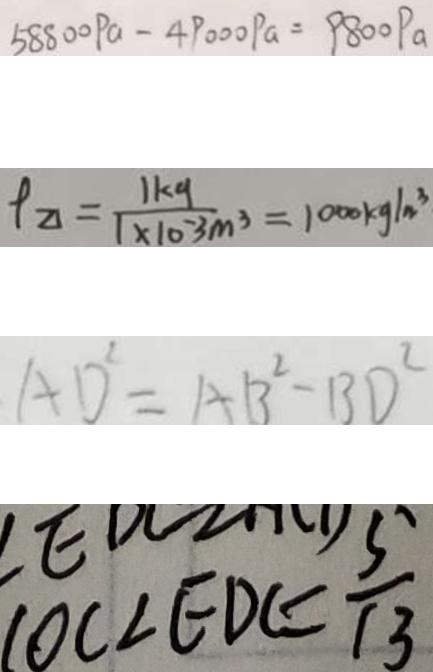Convert formula to latex. <formula><loc_0><loc_0><loc_500><loc_500>5 8 8 0 0 P a - 4 9 0 0 0 P a = 9 8 0 0 P a 
 \rho _ { \Delta } = \frac { 1 k g } { 1 \times 1 0 ^ { - 3 } m ^ { 3 } } = 1 0 0 0 k g / m ^ { 3 } 
 A D ^ { 2 } = A B ^ { 2 } - B D ^ { 2 } 
 \cos \angle E D C = \frac { 5 } { 1 3 }</formula> 